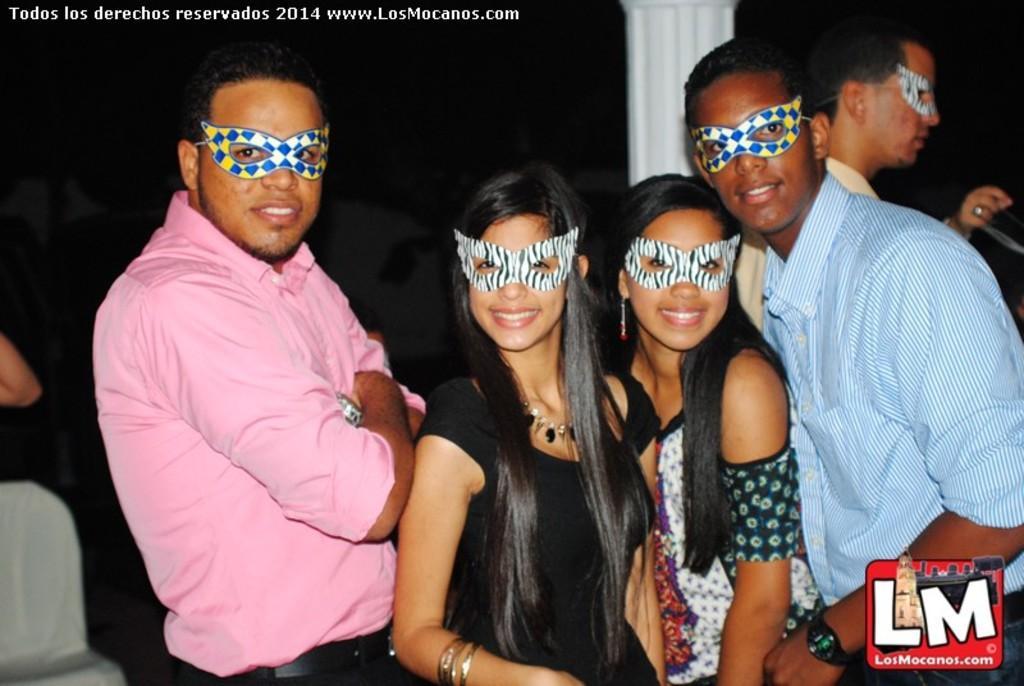Can you describe this image briefly? It looks like the picture is taken from some website there are a group of people in the foreground they are standing and posing for the photo, they are wearing masks to their eyes and there is some text at the bottom right corner of the image and top left corner of the image. 